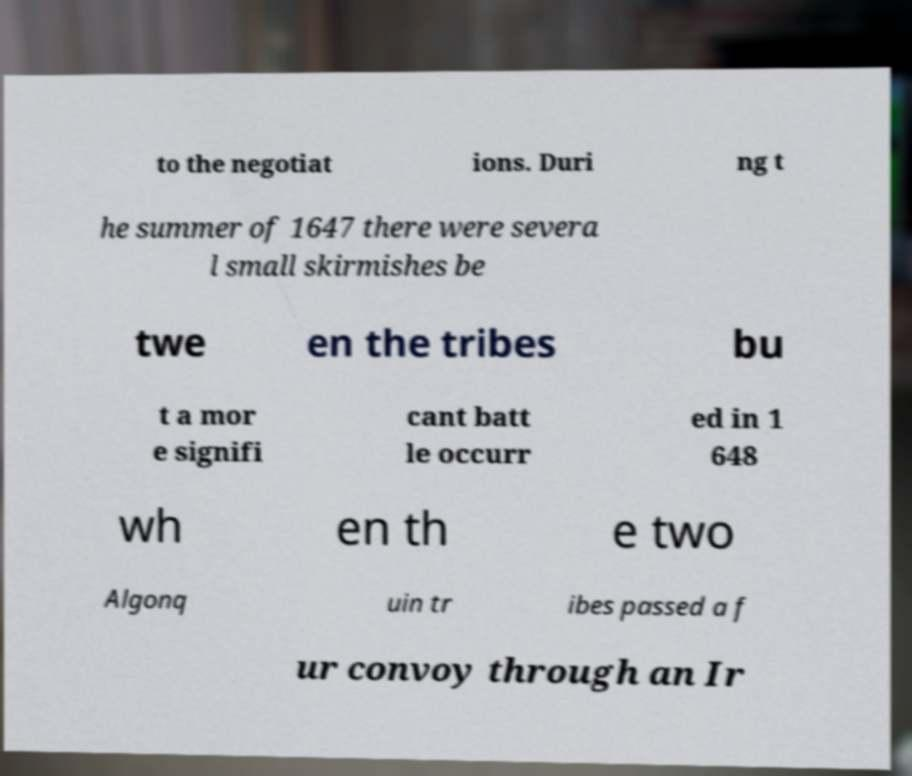Please read and relay the text visible in this image. What does it say? to the negotiat ions. Duri ng t he summer of 1647 there were severa l small skirmishes be twe en the tribes bu t a mor e signifi cant batt le occurr ed in 1 648 wh en th e two Algonq uin tr ibes passed a f ur convoy through an Ir 